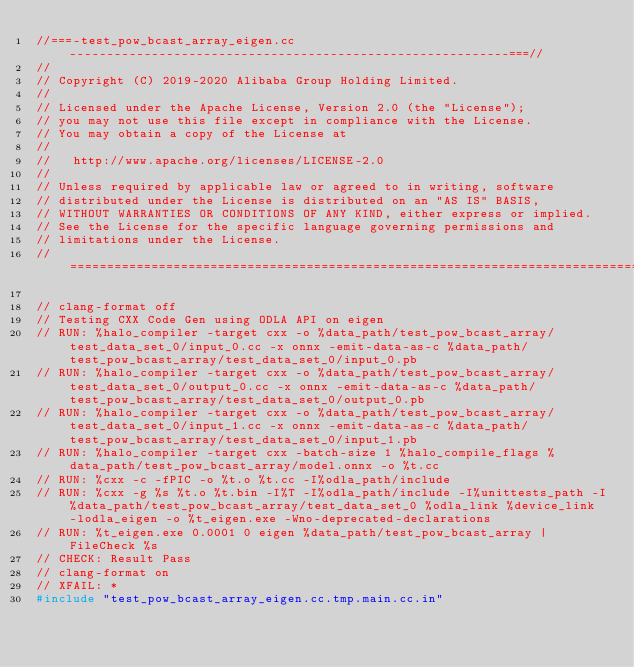Convert code to text. <code><loc_0><loc_0><loc_500><loc_500><_C++_>//===-test_pow_bcast_array_eigen.cc-----------------------------------------------------------===//
//
// Copyright (C) 2019-2020 Alibaba Group Holding Limited.
//
// Licensed under the Apache License, Version 2.0 (the "License");
// you may not use this file except in compliance with the License.
// You may obtain a copy of the License at
//
//   http://www.apache.org/licenses/LICENSE-2.0
//
// Unless required by applicable law or agreed to in writing, software
// distributed under the License is distributed on an "AS IS" BASIS,
// WITHOUT WARRANTIES OR CONDITIONS OF ANY KIND, either express or implied.
// See the License for the specific language governing permissions and
// limitations under the License.
// =============================================================================

// clang-format off
// Testing CXX Code Gen using ODLA API on eigen
// RUN: %halo_compiler -target cxx -o %data_path/test_pow_bcast_array/test_data_set_0/input_0.cc -x onnx -emit-data-as-c %data_path/test_pow_bcast_array/test_data_set_0/input_0.pb
// RUN: %halo_compiler -target cxx -o %data_path/test_pow_bcast_array/test_data_set_0/output_0.cc -x onnx -emit-data-as-c %data_path/test_pow_bcast_array/test_data_set_0/output_0.pb
// RUN: %halo_compiler -target cxx -o %data_path/test_pow_bcast_array/test_data_set_0/input_1.cc -x onnx -emit-data-as-c %data_path/test_pow_bcast_array/test_data_set_0/input_1.pb
// RUN: %halo_compiler -target cxx -batch-size 1 %halo_compile_flags %data_path/test_pow_bcast_array/model.onnx -o %t.cc
// RUN: %cxx -c -fPIC -o %t.o %t.cc -I%odla_path/include
// RUN: %cxx -g %s %t.o %t.bin -I%T -I%odla_path/include -I%unittests_path -I%data_path/test_pow_bcast_array/test_data_set_0 %odla_link %device_link -lodla_eigen -o %t_eigen.exe -Wno-deprecated-declarations
// RUN: %t_eigen.exe 0.0001 0 eigen %data_path/test_pow_bcast_array | FileCheck %s
// CHECK: Result Pass
// clang-format on
// XFAIL: *
#include "test_pow_bcast_array_eigen.cc.tmp.main.cc.in"
</code> 